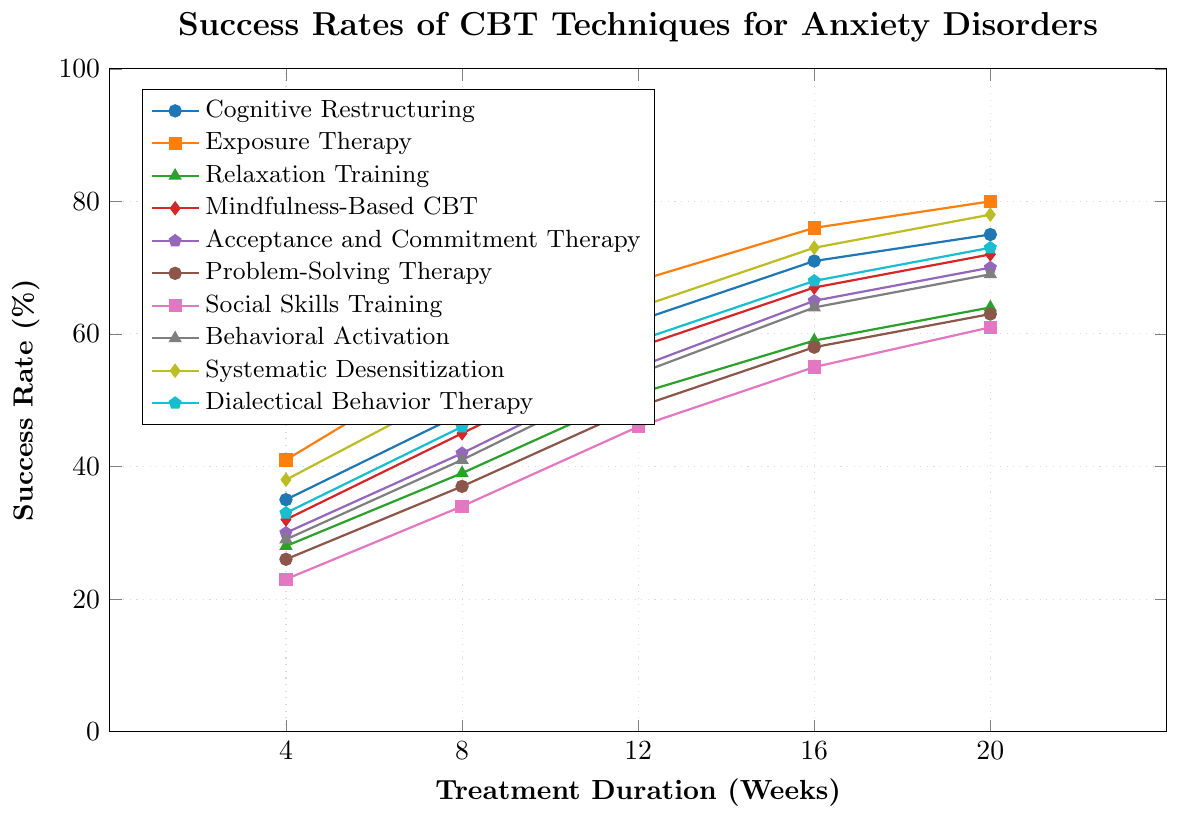Which CBT technique has the highest success rate at 20 weeks? To find the CBT technique with the highest success rate, look at the end of each line at the 20-week point. The highest point corresponds to Exposure Therapy at 80%.
Answer: Exposure Therapy Which two techniques have the closest success rates at 16 weeks? Examine the success rates at 16 weeks for all techniques. Both Acceptance and Commitment Therapy and Behavioral Activation have success rates of 64%, which are closest to each other.
Answer: Acceptance and Commitment Therapy and Behavioral Activation What is the difference in success rates between Cognitive Restructuring and Relaxation Training at 12 weeks? Note the success rates for both Cognitive Restructuring (62%) and Relaxation Training (51%) at 12 weeks. The difference is 62 - 51 = 11%.
Answer: 11% What is the average success rate of Mindfulness-Based CBT over all the time points? Add the success rates for Mindfulness-Based CBT at each time point: 32 + 45 + 58 + 67 + 72 = 274. Then, divide this sum by the number of time points, which is 5: 274 / 5 = 54.8.
Answer: 54.8% Which technique shows the greatest improvement in success rate from 4 weeks to 20 weeks? Calculate the improvement for each technique from 4 weeks to 20 weeks and find the maximum one. Systematic Desensitization improves from 38% to 78%, an increase of 40%. This is the highest improvement.
Answer: Systematic Desensitization How do the success rates of Systematic Desensitization and Dialectical Behavior Therapy compare across all time points? Compare the success rates at each time point:
- 4 weeks: Systematic Desensitization (38%) vs Dialectical Behavior Therapy (33%)
- 8 weeks: Systematic Desensitization (52%) vs Dialectical Behavior Therapy (46%)
- 12 weeks: Systematic Desensitization (64%) vs Dialectical Behavior Therapy (59%)
- 16 weeks: Systematic Desensitization (73%) vs Dialectical Behavior Therapy (68%)
- 20 weeks: Systematic Desensitization (78%) vs Dialectical Behavior Therapy (73%)
In all time points, Systematic Desensitization consistently has higher success rates than Dialectical Behavior Therapy.
Answer: Systematic Desensitization consistently higher What visual feature helps identify the success rate trend of Relaxation Training? The color and marker shape are key visual features; Relaxation Training is represented by a green line with triangle markers. It helps to easily follow the trend of success rates over the weeks.
Answer: Green line with triangle markers Find the median success rate at 16 weeks across all techniques. List the success rates at 16 weeks in order: 55, 58, 64, 65, 67, 68, 71, 73, 76. Since there are 10 values, the median is the average of the 5th and 6th values: (65 + 67) / 2 = 66%.
Answer: 66% Does Behavioral Activation outperform Social Skills Training at any point during the treatment? Compare success rates at each week:
- 4 weeks: Behavioral Activation (29%) vs Social Skills Training (23%)
- 8 weeks: Behavioral Activation (41%) vs Social Skills Training (34%)
- 12 weeks: Behavioral Activation (54%) vs Social Skills Training (46%)
- 16 weeks: Behavioral Activation (64%) vs Social Skills Training (55%)
- 20 weeks: Behavioral Activation (69%) vs Social Skills Training (61%)
Behavioral Activation outperforms Social Skills Training at all points.
Answer: Yes What is the range of success rates for Social Skills Training over the treatment duration? Find the minimum and maximum values for Social Skills Training: minimum (23% at 4 weeks) and maximum (61% at 20 weeks). The range is 61 - 23 = 38%.
Answer: 38% 